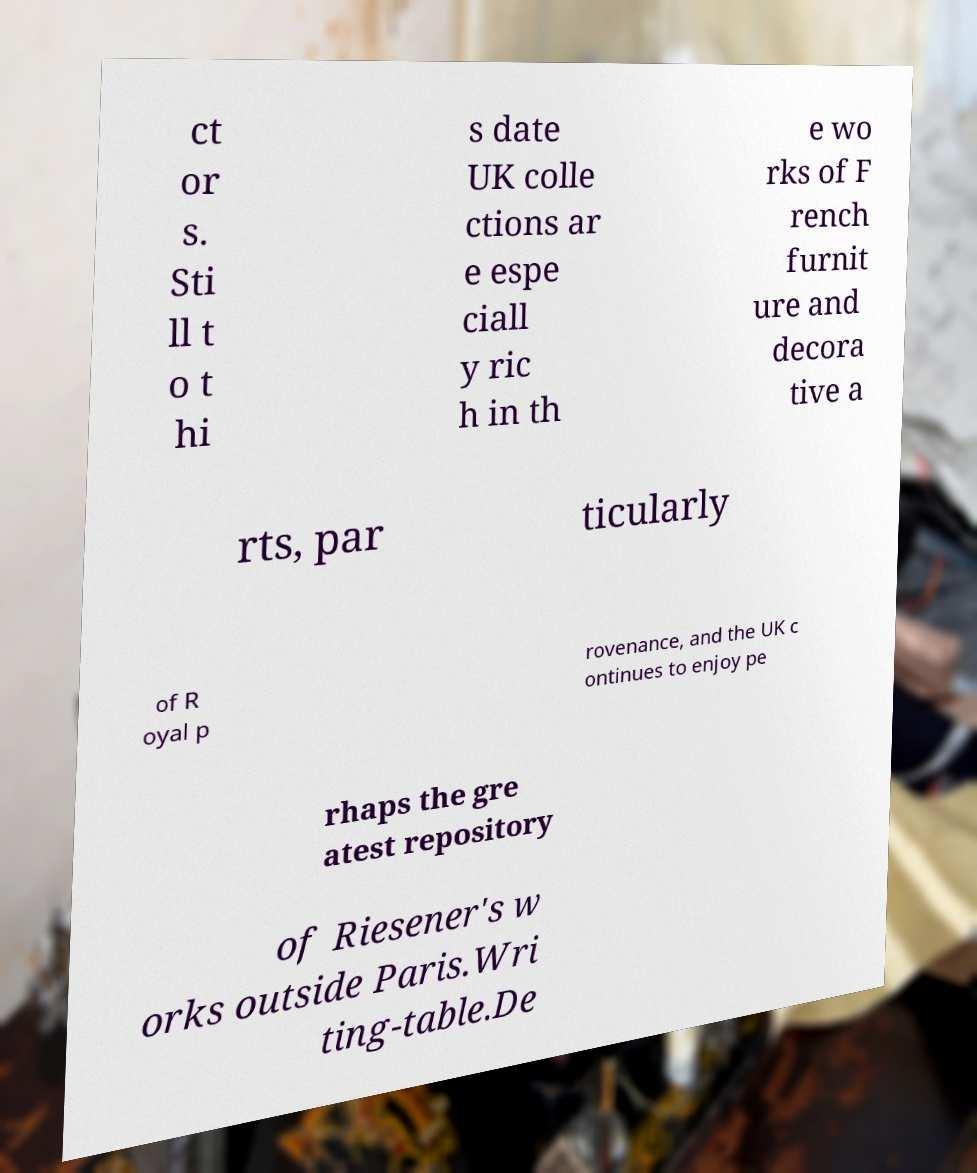For documentation purposes, I need the text within this image transcribed. Could you provide that? ct or s. Sti ll t o t hi s date UK colle ctions ar e espe ciall y ric h in th e wo rks of F rench furnit ure and decora tive a rts, par ticularly of R oyal p rovenance, and the UK c ontinues to enjoy pe rhaps the gre atest repository of Riesener's w orks outside Paris.Wri ting-table.De 